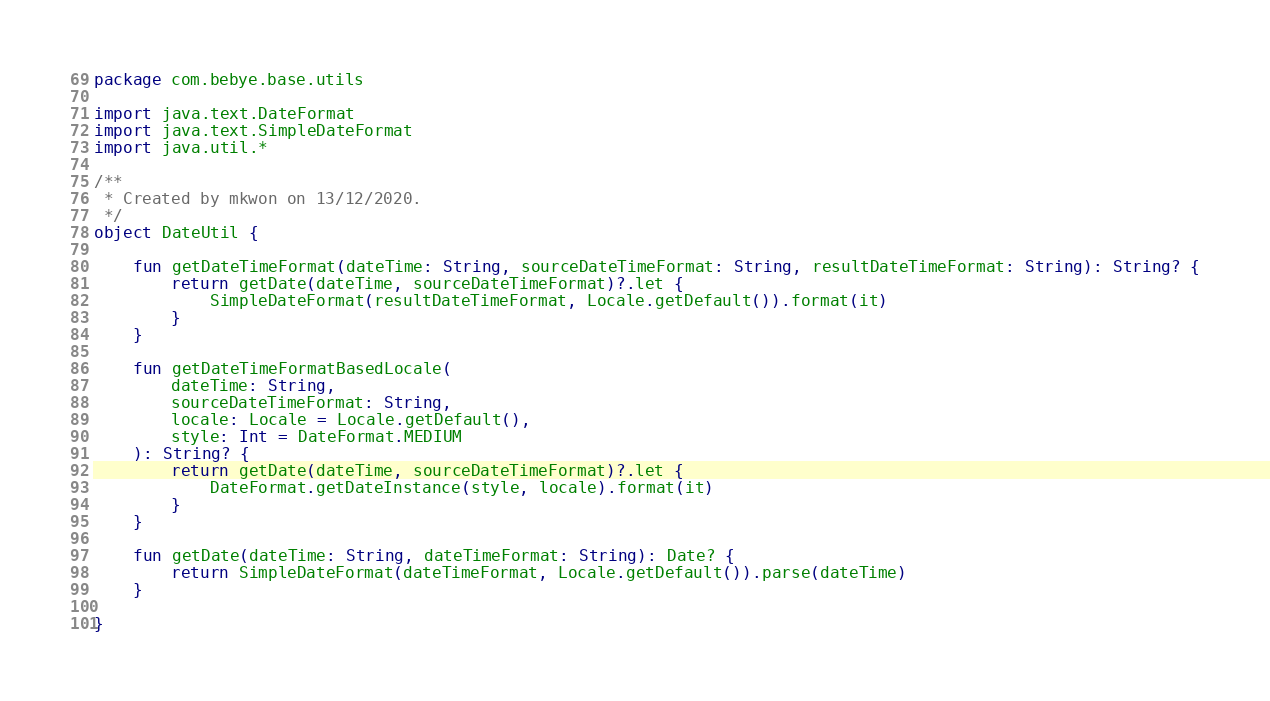<code> <loc_0><loc_0><loc_500><loc_500><_Kotlin_>package com.bebye.base.utils

import java.text.DateFormat
import java.text.SimpleDateFormat
import java.util.*

/**
 * Created by mkwon on 13/12/2020.
 */
object DateUtil {

    fun getDateTimeFormat(dateTime: String, sourceDateTimeFormat: String, resultDateTimeFormat: String): String? {
        return getDate(dateTime, sourceDateTimeFormat)?.let {
            SimpleDateFormat(resultDateTimeFormat, Locale.getDefault()).format(it)
        }
    }

    fun getDateTimeFormatBasedLocale(
        dateTime: String,
        sourceDateTimeFormat: String,
        locale: Locale = Locale.getDefault(),
        style: Int = DateFormat.MEDIUM
    ): String? {
        return getDate(dateTime, sourceDateTimeFormat)?.let {
            DateFormat.getDateInstance(style, locale).format(it)
        }
    }

    fun getDate(dateTime: String, dateTimeFormat: String): Date? {
        return SimpleDateFormat(dateTimeFormat, Locale.getDefault()).parse(dateTime)
    }

}</code> 